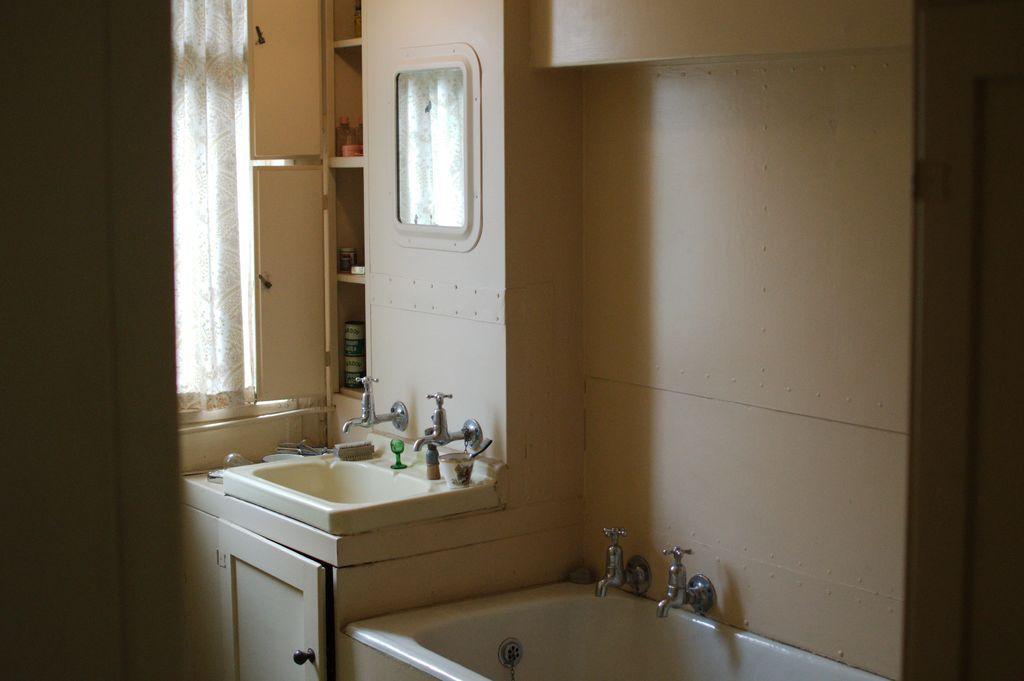Could you give a brief overview of what you see in this image? In this image we can see an inner view of a bathroom containing a sink with two taps, cupboard, bath tub with two taps, wall, mirror and a bowl. We can also see a window with curtain. 